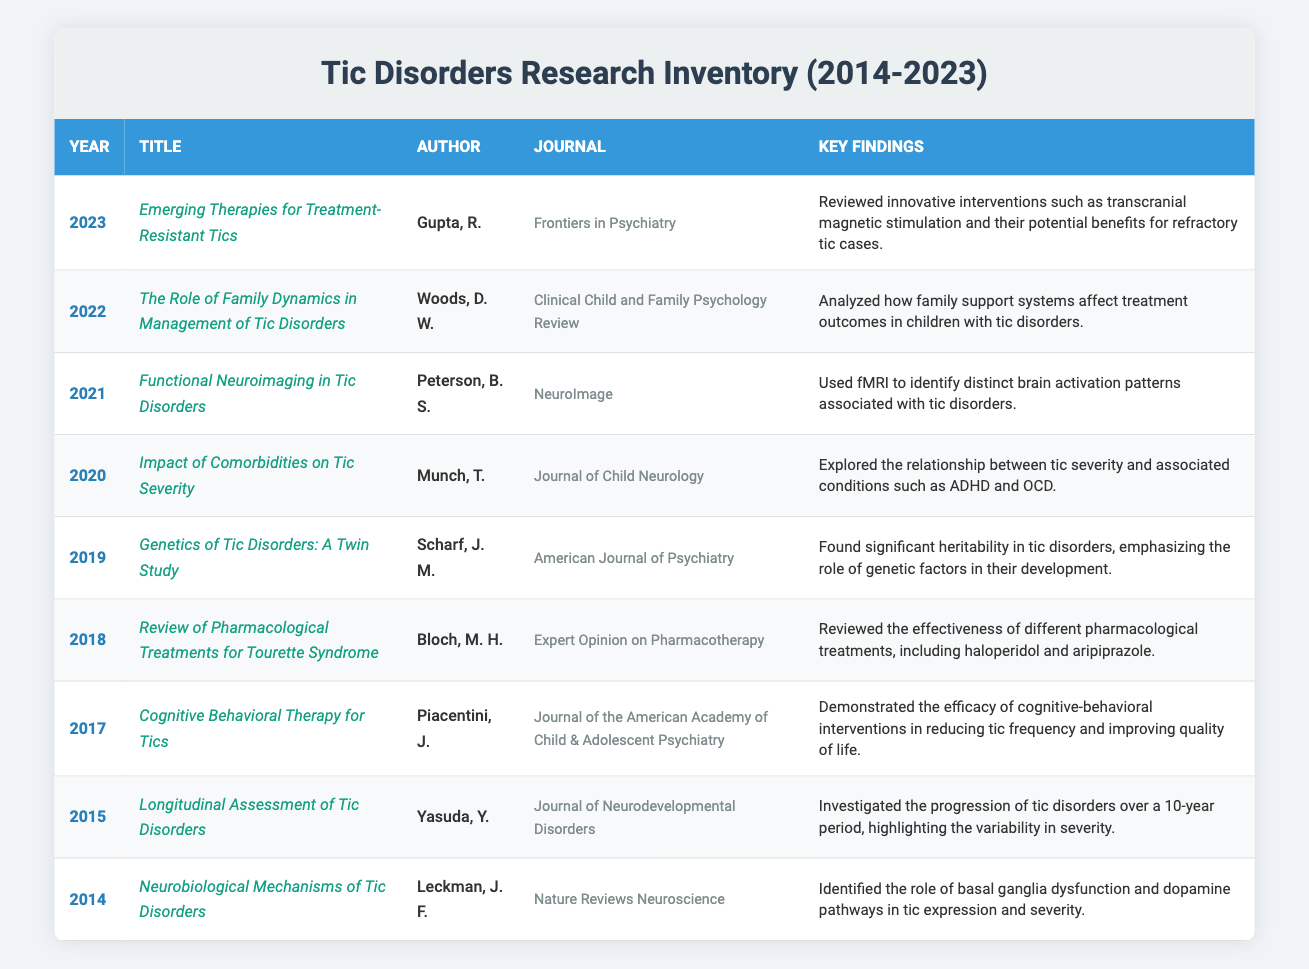What year was the publication "Emerging Therapies for Treatment-Resistant Tics"? The title "Emerging Therapies for Treatment-Resistant Tics" is listed in the row for the year 2023.
Answer: 2023 Who authored the publication titled "Functional Neuroimaging in Tic Disorders"? The publication "Functional Neuroimaging in Tic Disorders" is attributed to Peterson, B. S.
Answer: Peterson, B. S How many publications focus on the psychological aspects of tic disorders? The table shows two publications related to psychological treatments: "Cognitive Behavioral Therapy for Tics" and "The Role of Family Dynamics in Management of Tic Disorders," leading to a total of 2 publications.
Answer: 2 What findings were reported in the 2019 publication? In 2019, the publication "Genetics of Tic Disorders: A Twin Study" found significant heritability in tic disorders, emphasizing the role of genetic factors in their development.
Answer: Significant heritability in tic disorders Did any publication in 2020 discuss the impact of comorbidities on tic severity? Yes, the publication titled "Impact of Comorbidities on Tic Severity" in 2020 directedly addressed this topic.
Answer: Yes What is the difference in publication years between the first and last publication listed in the table? The first publication is from 2014 and the last from 2023. Therefore, the difference in publication years is 2023 - 2014 = 9 years.
Answer: 9 years Which author has worked on multiple publications? The author Piacentini, J. has contributed to "Cognitive Behavioral Therapy for Tics" in 2017 and has also contributed to other works related to tic disorders; however, no other author appears in multiple papers based on the titles presented.
Answer: Piacentini, J How many years passed between the first publication and the publication discussing family dynamics in tic disorders? The first publication was in 2014 and the family dynamics publication was in 2022. The difference in years is calculated as 2022 - 2014 = 8 years.
Answer: 8 years Is there a publication that discusses both pharmacological treatments and psychological interventions? No, the publications in the table focus separately on pharmacological treatments and psychological interventions without overlapping themes.
Answer: No 